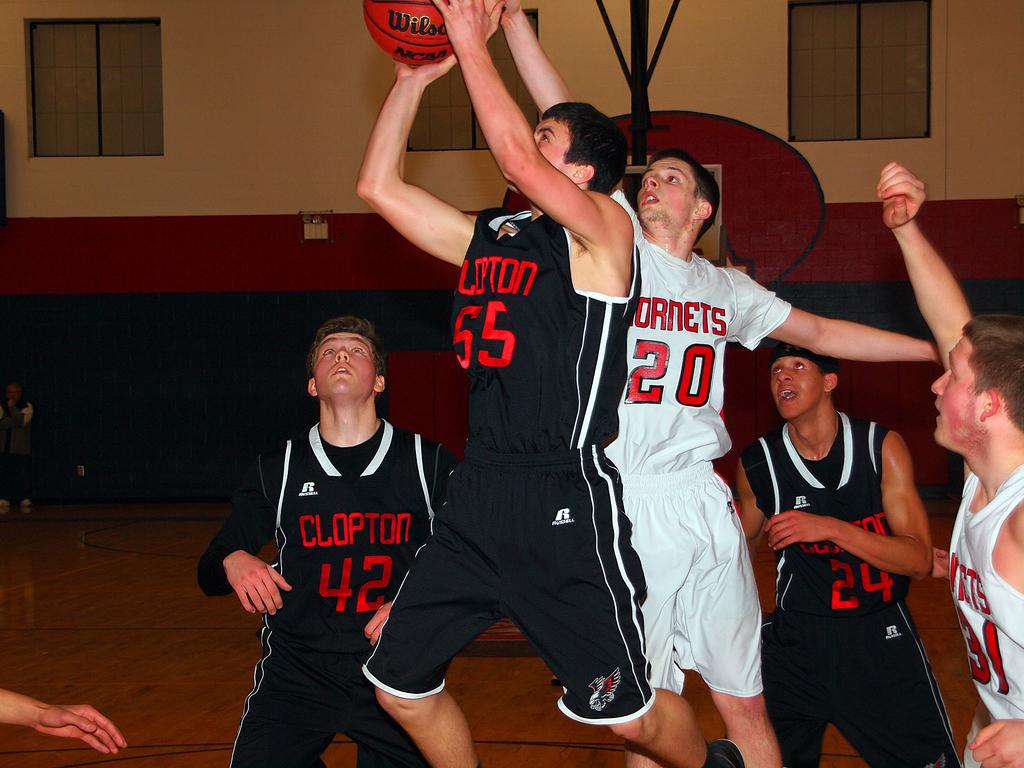<image>
Provide a brief description of the given image. Player 20 is on the Hornets basketball team. 